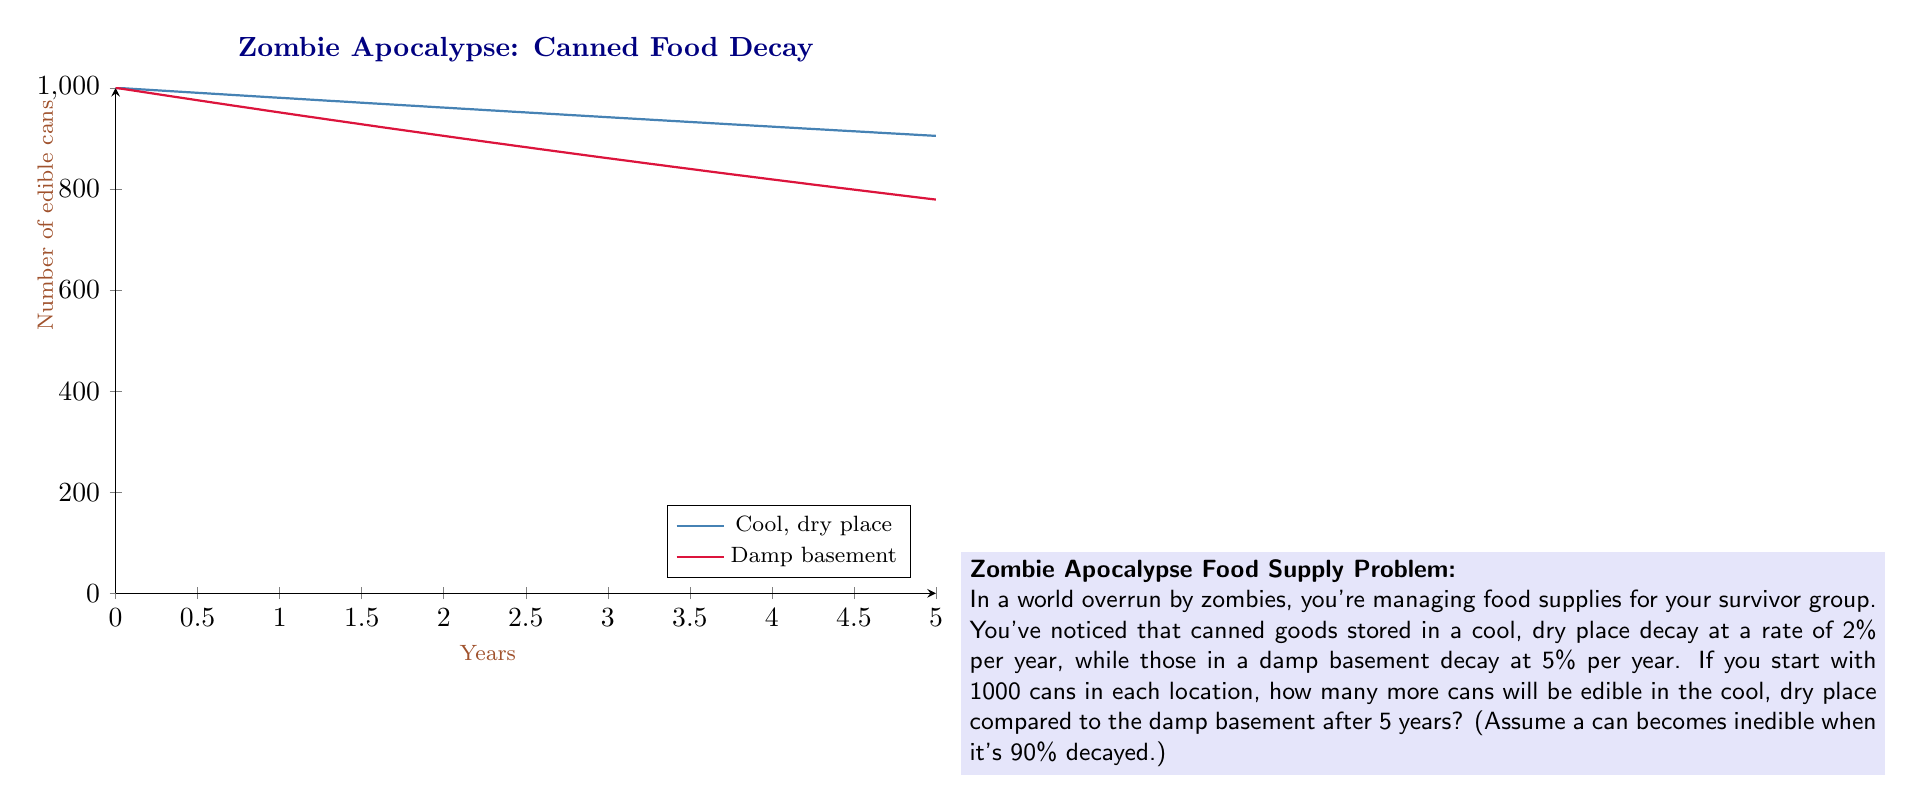Provide a solution to this math problem. Let's approach this step-by-step:

1) First, we need to calculate the number of edible cans in each location after 5 years.

2) For exponential decay, we use the formula:
   $$N(t) = N_0 * e^{-rt}$$
   where $N(t)$ is the quantity at time $t$, $N_0$ is the initial quantity, $r$ is the decay rate, and $t$ is time.

3) For the cool, dry place:
   $$N(5) = 1000 * e^{-0.02 * 5} \approx 904.84$$

4) For the damp basement:
   $$N(5) = 1000 * e^{-0.05 * 5} \approx 778.80$$

5) However, we need to check if these numbers are above 90% decay:
   90% of 1000 is 100, so any number above 100 is considered edible.
   Both numbers are above 100, so all these cans are still edible.

6) To find the difference, we subtract:
   $$904.84 - 778.80 = 126.04$$

7) Since we're dealing with whole cans, we round down to 126.
Answer: 126 cans 